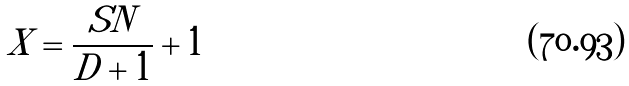Convert formula to latex. <formula><loc_0><loc_0><loc_500><loc_500>X = \frac { S N } { D + 1 } + 1</formula> 